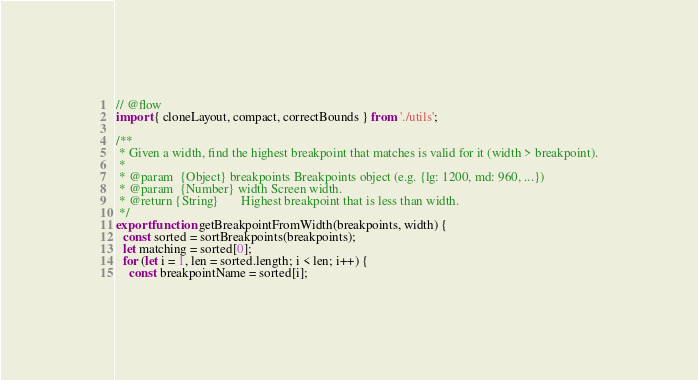Convert code to text. <code><loc_0><loc_0><loc_500><loc_500><_JavaScript_>// @flow
import { cloneLayout, compact, correctBounds } from './utils';

/**
 * Given a width, find the highest breakpoint that matches is valid for it (width > breakpoint).
 *
 * @param  {Object} breakpoints Breakpoints object (e.g. {lg: 1200, md: 960, ...})
 * @param  {Number} width Screen width.
 * @return {String}       Highest breakpoint that is less than width.
 */
export function getBreakpointFromWidth(breakpoints, width) {
  const sorted = sortBreakpoints(breakpoints);
  let matching = sorted[0];
  for (let i = 1, len = sorted.length; i < len; i++) {
    const breakpointName = sorted[i];</code> 